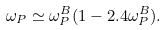<formula> <loc_0><loc_0><loc_500><loc_500>\omega _ { P } \simeq \omega _ { P } ^ { B } ( 1 - 2 . 4 \omega _ { P } ^ { B } ) .</formula> 